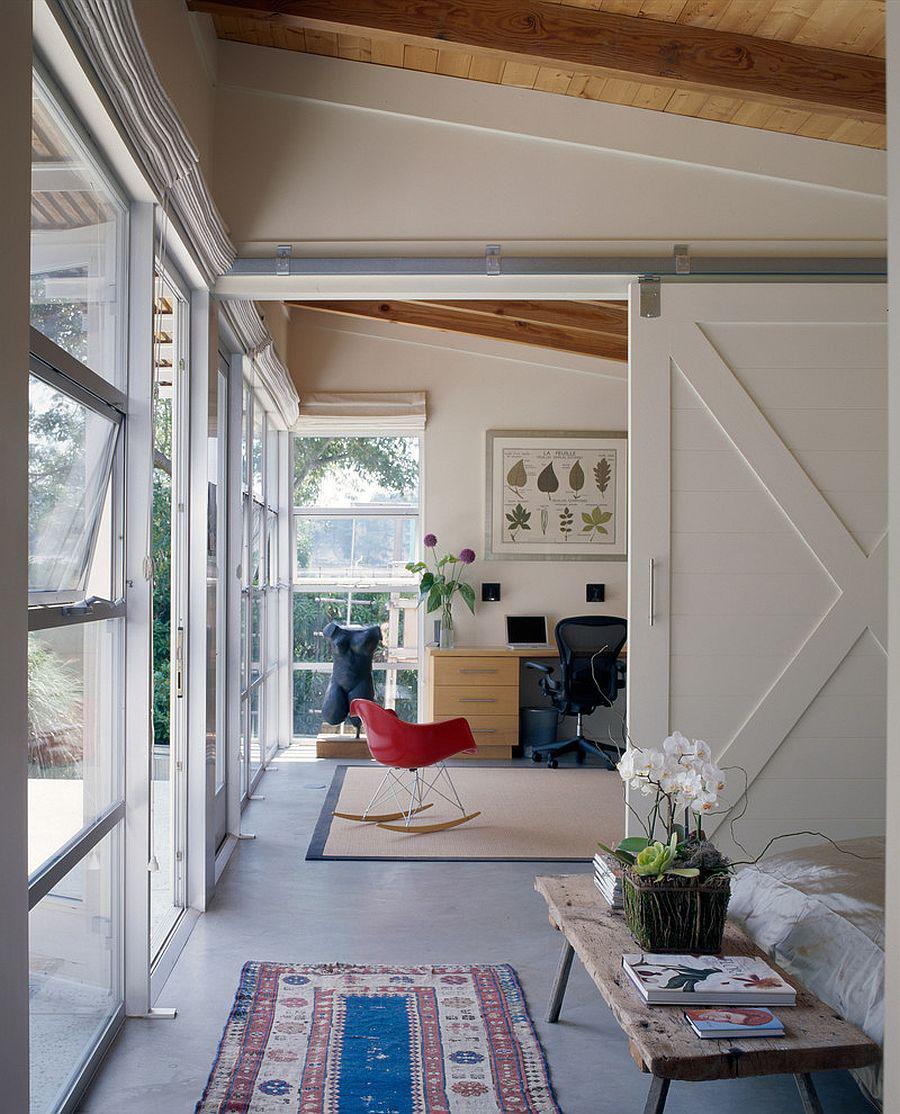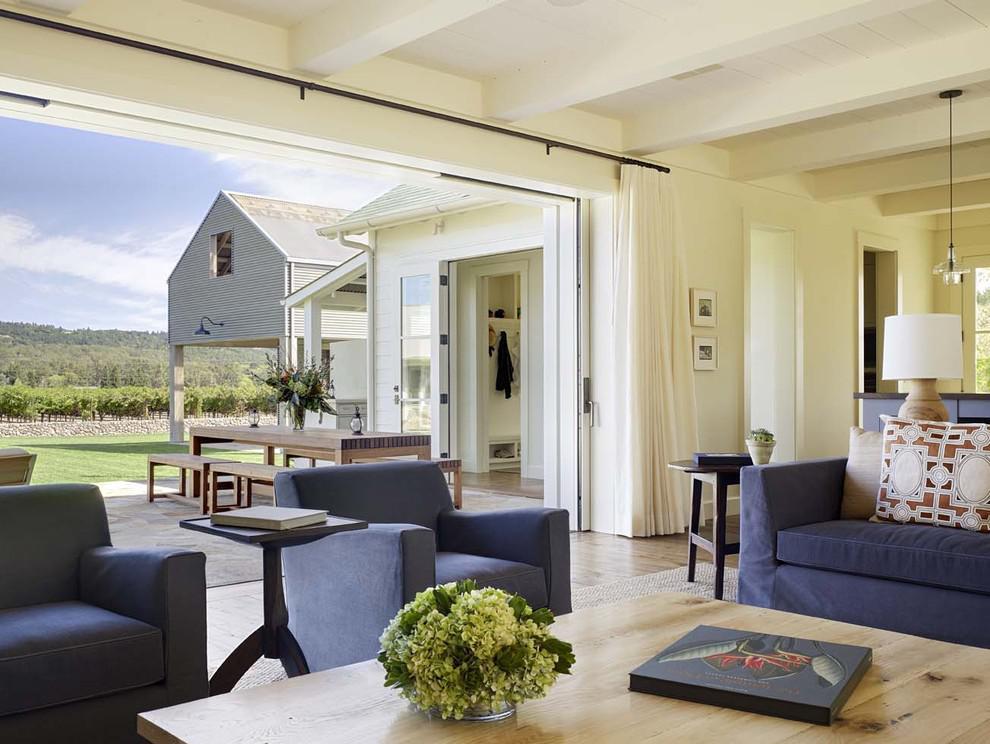The first image is the image on the left, the second image is the image on the right. For the images shown, is this caption "In at least one image there is at least one hanging wooden door on a track." true? Answer yes or no. Yes. 